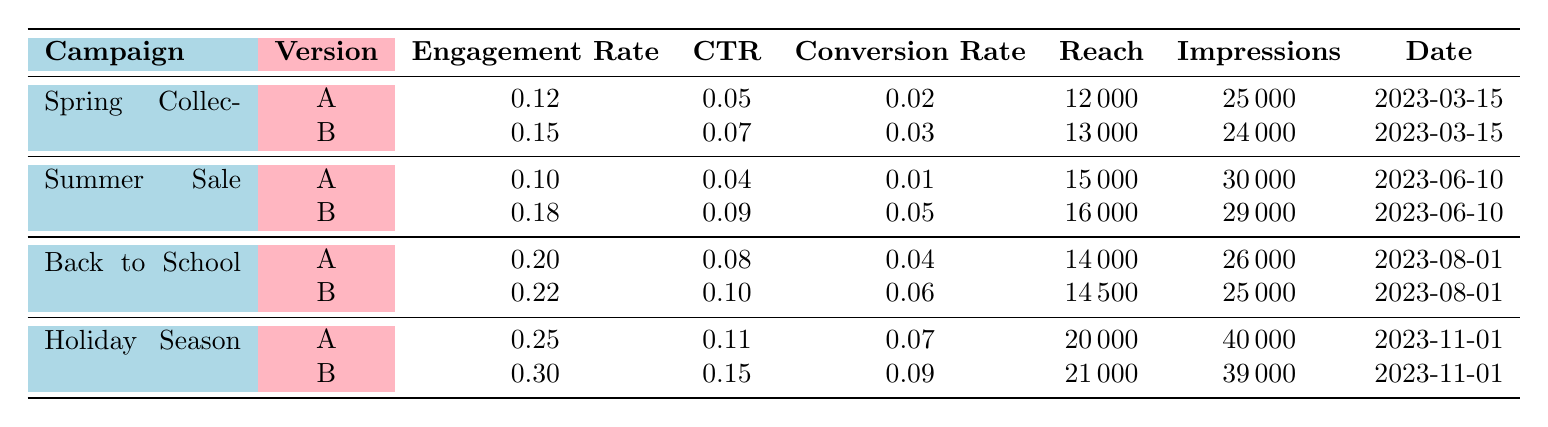What was the highest Engagement Rate among the campaigns? The Engagement Rates for each campaign are as follows: Spring Collection Launch (0.12, 0.15), Summer Sale Campaign (0.10, 0.18), Back to School Launch (0.20, 0.22), Holiday Season Special (0.25, 0.30). The highest is 0.30 from Version B of the Holiday Season Special.
Answer: 0.30 Which graphic version had a higher Click Through Rate in the Back to School Launch? For the Back to School Launch, Version A has a Click Through Rate of 0.08 and Version B has 0.10. Thus, Version B has the higher rate.
Answer: Version B What is the difference in Conversion Rates between the Summer Sale Campaign's two graphic versions? The Conversion Rates are as follows: Version A has 0.01 and Version B has 0.05. The difference is 0.05 - 0.01 = 0.04.
Answer: 0.04 How many more impressions did the Holiday Season Special generate compared to the Spring Collection Launch? The Holiday Season Special had 40,000 impressions, while the Spring Collection Launch had 25,000. The difference is 40,000 - 25,000 = 15,000.
Answer: 15,000 Was the Click Through Rate for the Summer Sale Campaign's Version B greater than the Engagement Rate for Version A? Version B of the Summer Sale Campaign has a Click Through Rate of 0.09 and Version A has an Engagement Rate of 0.10. Since 0.09 is less than 0.10, the statement is false.
Answer: No What was the average Engagement Rate for both versions of the Back to School Launch? The Engagement Rates for the Back to School Launch are 0.20 and 0.22. To get the average, calculate (0.20 + 0.22) / 2 = 0.21.
Answer: 0.21 Did Version B of the Holiday Season Special reach more people than Version A of the Spring Collection Launch? Version B of the Holiday Season Special reached 21,000 people, while Version A of the Spring Collection Launch reached 12,000. Since 21,000 is greater than 12,000, this statement is true.
Answer: Yes What is the total reach for both graphic versions of the Summer Sale Campaign? For the Summer Sale Campaign, Version A reached 15,000 and Version B reached 16,000. The total reach is 15,000 + 16,000 = 31,000.
Answer: 31,000 How does the Conversion Rate of Version A in the Holiday Season Special compare to that in the Spring Collection Launch? Version A of the Holiday Season Special has a Conversion Rate of 0.07, while Version A of the Spring Collection Launch has 0.02. Since 0.07 is greater than 0.02, it is higher.
Answer: Higher Which graphic version had the highest Conversion Rate across all campaigns? Looking through the data, Version B of the Holiday Season Special has the highest Conversion Rate at 0.09 compared to all other versions.
Answer: Version B of the Holiday Season Special 